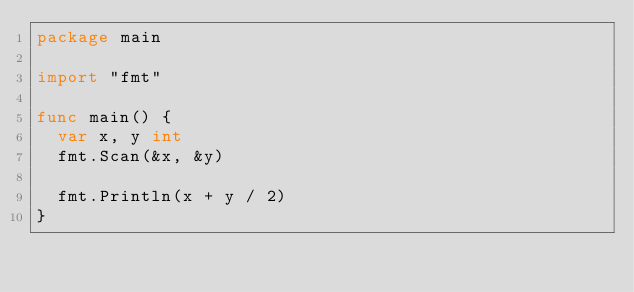<code> <loc_0><loc_0><loc_500><loc_500><_Go_>package main

import "fmt"

func main() {
  var x, y int
  fmt.Scan(&x, &y)
  
  fmt.Println(x + y / 2)
}</code> 